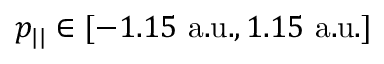Convert formula to latex. <formula><loc_0><loc_0><loc_500><loc_500>p _ { | | } \in [ - 1 . 1 5 a . u . , 1 . 1 5 a . u . ]</formula> 